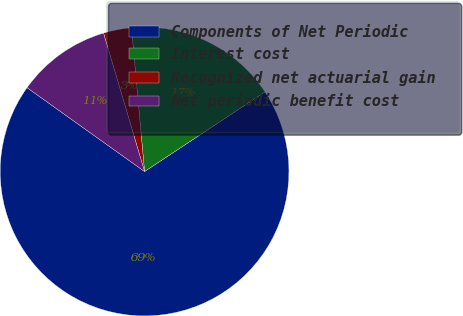Convert chart to OTSL. <chart><loc_0><loc_0><loc_500><loc_500><pie_chart><fcel>Components of Net Periodic<fcel>Interest cost<fcel>Recognized net actuarial gain<fcel>Net periodic benefit cost<nl><fcel>69.17%<fcel>17.15%<fcel>3.14%<fcel>10.55%<nl></chart> 